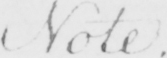Please transcribe the handwritten text in this image. Note . 